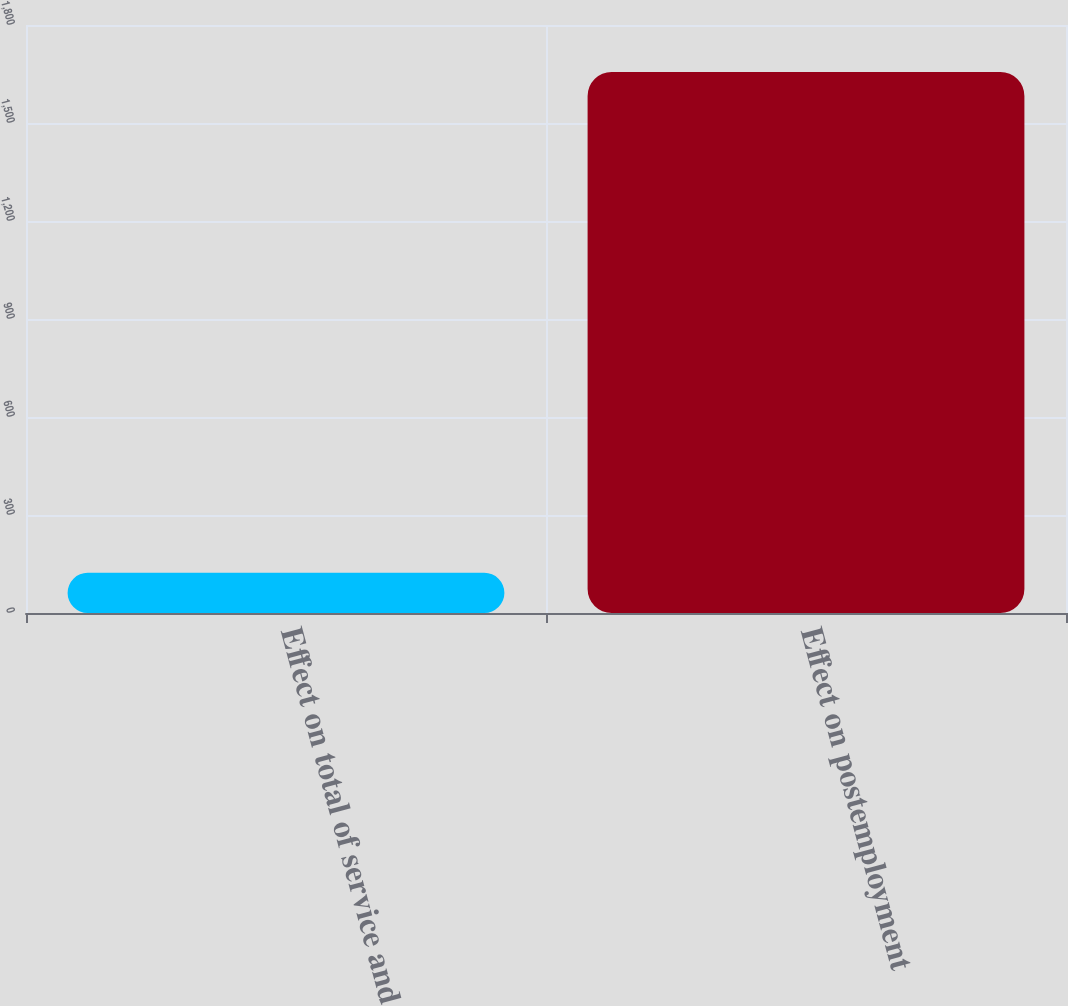Convert chart to OTSL. <chart><loc_0><loc_0><loc_500><loc_500><bar_chart><fcel>Effect on total of service and<fcel>Effect on postemployment<nl><fcel>123<fcel>1656<nl></chart> 